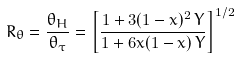Convert formula to latex. <formula><loc_0><loc_0><loc_500><loc_500>R _ { \theta } = \frac { \theta _ { H } } { \theta _ { \tau } } = \left [ \frac { 1 + 3 ( 1 - x ) ^ { 2 } \, Y } { 1 + 6 x ( 1 - x ) \, Y } \right ] ^ { 1 / 2 }</formula> 